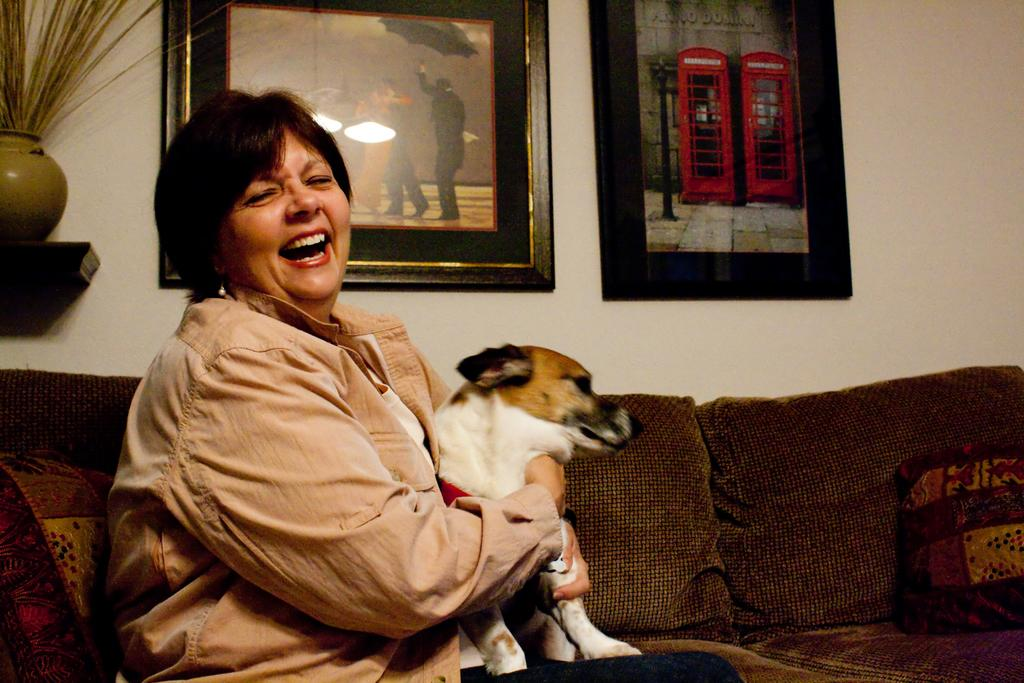Who is the main subject in the image? There is a woman in the image. What is the woman doing in the image? The woman is sitting on a sofa and has her hands spread around a dog. What is the position of the dog in the image? There is a dog sitting beside the woman. What type of wall can be seen in the image? There is no wall visible in the image; it features a woman sitting on a sofa with a dog. 